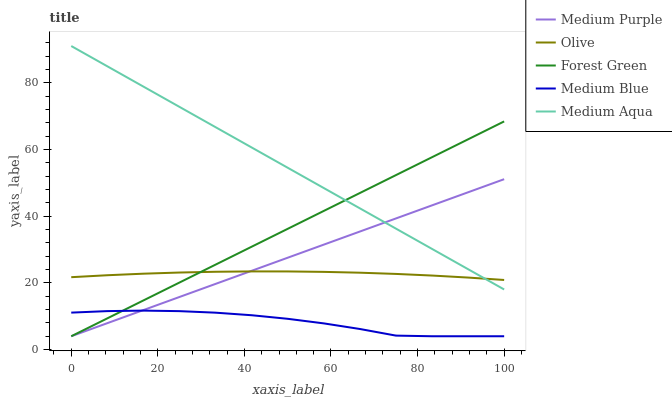Does Medium Blue have the minimum area under the curve?
Answer yes or no. Yes. Does Medium Aqua have the maximum area under the curve?
Answer yes or no. Yes. Does Olive have the minimum area under the curve?
Answer yes or no. No. Does Olive have the maximum area under the curve?
Answer yes or no. No. Is Forest Green the smoothest?
Answer yes or no. Yes. Is Medium Blue the roughest?
Answer yes or no. Yes. Is Olive the smoothest?
Answer yes or no. No. Is Olive the roughest?
Answer yes or no. No. Does Medium Purple have the lowest value?
Answer yes or no. Yes. Does Olive have the lowest value?
Answer yes or no. No. Does Medium Aqua have the highest value?
Answer yes or no. Yes. Does Olive have the highest value?
Answer yes or no. No. Is Medium Blue less than Medium Aqua?
Answer yes or no. Yes. Is Olive greater than Medium Blue?
Answer yes or no. Yes. Does Medium Blue intersect Forest Green?
Answer yes or no. Yes. Is Medium Blue less than Forest Green?
Answer yes or no. No. Is Medium Blue greater than Forest Green?
Answer yes or no. No. Does Medium Blue intersect Medium Aqua?
Answer yes or no. No. 